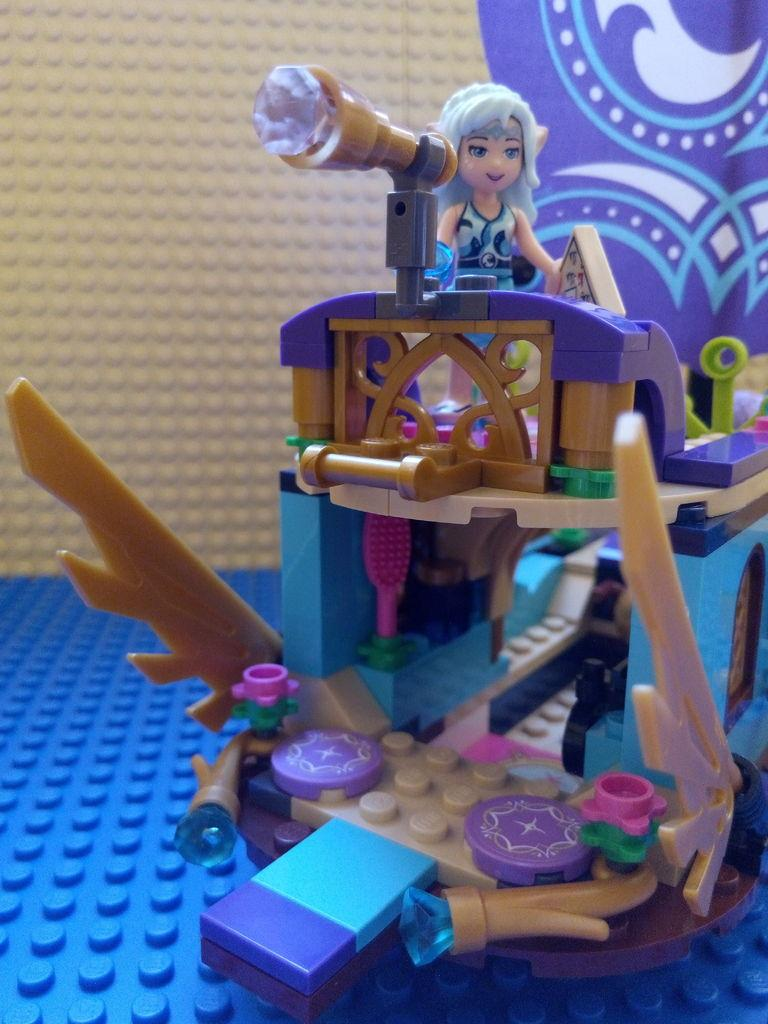What type of toy is present in the image? There is a Lego toy in the image. What page number is the Lego toy located on in the image? The image does not have page numbers, as it is not a book or document. 